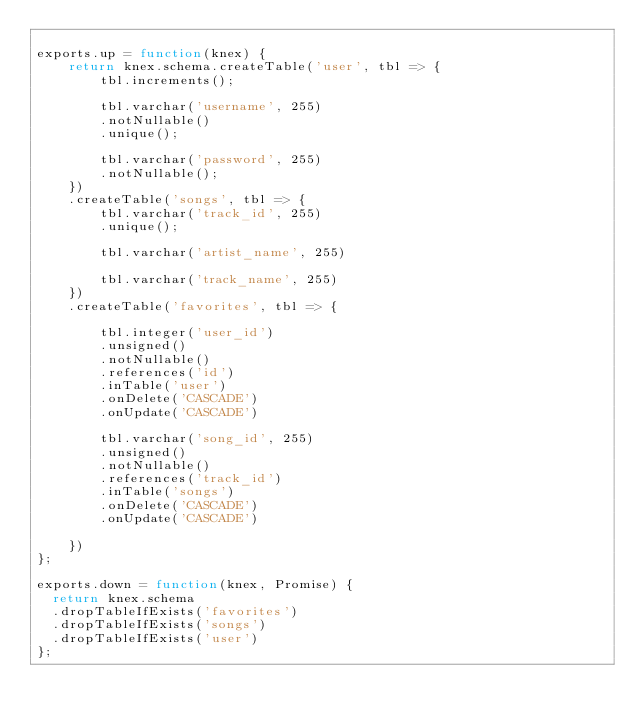Convert code to text. <code><loc_0><loc_0><loc_500><loc_500><_JavaScript_>
exports.up = function(knex) {
    return knex.schema.createTable('user', tbl => {
        tbl.increments();

        tbl.varchar('username', 255)
        .notNullable()
        .unique();

        tbl.varchar('password', 255)
        .notNullable();
    })
    .createTable('songs', tbl => {
        tbl.varchar('track_id', 255)
        .unique();

        tbl.varchar('artist_name', 255)

        tbl.varchar('track_name', 255)
    })
    .createTable('favorites', tbl => {

        tbl.integer('user_id')
        .unsigned()
        .notNullable()
        .references('id')
        .inTable('user')
        .onDelete('CASCADE')
        .onUpdate('CASCADE')

        tbl.varchar('song_id', 255)
        .unsigned()
        .notNullable()
        .references('track_id')
        .inTable('songs')
        .onDelete('CASCADE')
        .onUpdate('CASCADE')

    })
};

exports.down = function(knex, Promise) {
  return knex.schema
  .dropTableIfExists('favorites')
  .dropTableIfExists('songs')
  .dropTableIfExists('user')
};
</code> 